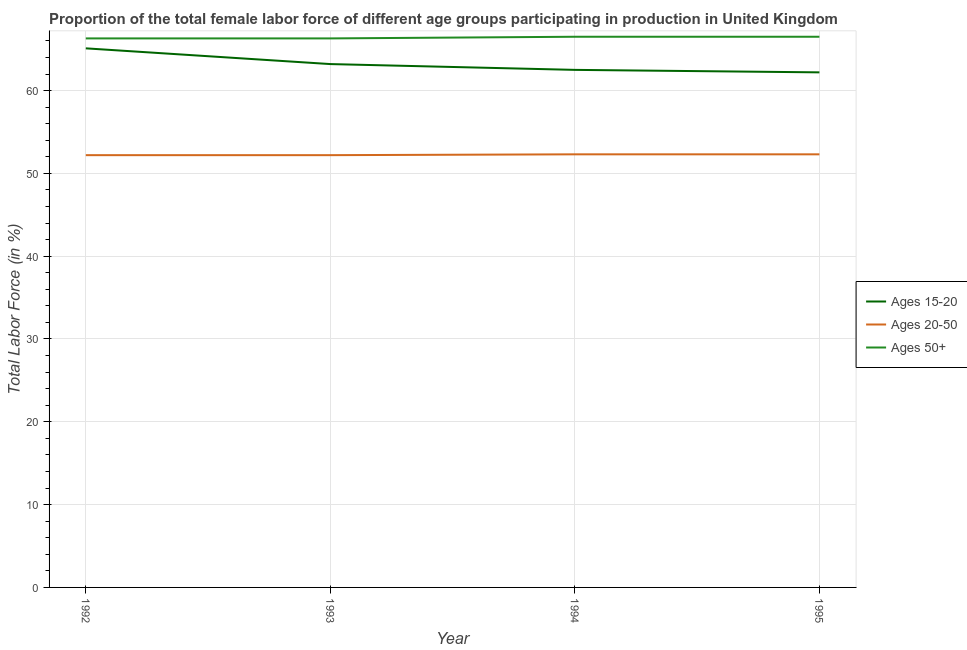How many different coloured lines are there?
Ensure brevity in your answer.  3. Is the number of lines equal to the number of legend labels?
Provide a short and direct response. Yes. What is the percentage of female labor force within the age group 15-20 in 1993?
Offer a very short reply. 63.2. Across all years, what is the maximum percentage of female labor force within the age group 20-50?
Keep it short and to the point. 52.3. Across all years, what is the minimum percentage of female labor force within the age group 20-50?
Provide a succinct answer. 52.2. In which year was the percentage of female labor force within the age group 20-50 maximum?
Give a very brief answer. 1994. What is the total percentage of female labor force within the age group 20-50 in the graph?
Your answer should be compact. 209. What is the difference between the percentage of female labor force above age 50 in 1993 and that in 1995?
Your answer should be compact. -0.2. What is the difference between the percentage of female labor force within the age group 20-50 in 1992 and the percentage of female labor force above age 50 in 1993?
Offer a very short reply. -14.1. What is the average percentage of female labor force within the age group 20-50 per year?
Provide a succinct answer. 52.25. In the year 1995, what is the difference between the percentage of female labor force within the age group 20-50 and percentage of female labor force within the age group 15-20?
Your response must be concise. -9.9. What is the ratio of the percentage of female labor force within the age group 15-20 in 1993 to that in 1995?
Give a very brief answer. 1.02. Is the percentage of female labor force above age 50 in 1992 less than that in 1995?
Your answer should be compact. Yes. What is the difference between the highest and the second highest percentage of female labor force within the age group 15-20?
Your answer should be compact. 1.9. What is the difference between the highest and the lowest percentage of female labor force above age 50?
Provide a short and direct response. 0.2. Is the sum of the percentage of female labor force within the age group 15-20 in 1993 and 1994 greater than the maximum percentage of female labor force within the age group 20-50 across all years?
Offer a terse response. Yes. Is the percentage of female labor force within the age group 15-20 strictly less than the percentage of female labor force above age 50 over the years?
Provide a short and direct response. Yes. How many years are there in the graph?
Provide a short and direct response. 4. What is the difference between two consecutive major ticks on the Y-axis?
Keep it short and to the point. 10. Where does the legend appear in the graph?
Your answer should be very brief. Center right. How many legend labels are there?
Keep it short and to the point. 3. How are the legend labels stacked?
Your answer should be compact. Vertical. What is the title of the graph?
Offer a terse response. Proportion of the total female labor force of different age groups participating in production in United Kingdom. Does "Errors" appear as one of the legend labels in the graph?
Provide a short and direct response. No. What is the label or title of the Y-axis?
Offer a terse response. Total Labor Force (in %). What is the Total Labor Force (in %) of Ages 15-20 in 1992?
Offer a very short reply. 65.1. What is the Total Labor Force (in %) of Ages 20-50 in 1992?
Ensure brevity in your answer.  52.2. What is the Total Labor Force (in %) of Ages 50+ in 1992?
Keep it short and to the point. 66.3. What is the Total Labor Force (in %) of Ages 15-20 in 1993?
Your response must be concise. 63.2. What is the Total Labor Force (in %) in Ages 20-50 in 1993?
Your answer should be compact. 52.2. What is the Total Labor Force (in %) of Ages 50+ in 1993?
Ensure brevity in your answer.  66.3. What is the Total Labor Force (in %) in Ages 15-20 in 1994?
Offer a very short reply. 62.5. What is the Total Labor Force (in %) of Ages 20-50 in 1994?
Make the answer very short. 52.3. What is the Total Labor Force (in %) of Ages 50+ in 1994?
Provide a succinct answer. 66.5. What is the Total Labor Force (in %) in Ages 15-20 in 1995?
Your response must be concise. 62.2. What is the Total Labor Force (in %) of Ages 20-50 in 1995?
Give a very brief answer. 52.3. What is the Total Labor Force (in %) in Ages 50+ in 1995?
Provide a short and direct response. 66.5. Across all years, what is the maximum Total Labor Force (in %) in Ages 15-20?
Your answer should be compact. 65.1. Across all years, what is the maximum Total Labor Force (in %) of Ages 20-50?
Provide a succinct answer. 52.3. Across all years, what is the maximum Total Labor Force (in %) in Ages 50+?
Keep it short and to the point. 66.5. Across all years, what is the minimum Total Labor Force (in %) of Ages 15-20?
Your response must be concise. 62.2. Across all years, what is the minimum Total Labor Force (in %) in Ages 20-50?
Offer a terse response. 52.2. Across all years, what is the minimum Total Labor Force (in %) in Ages 50+?
Provide a succinct answer. 66.3. What is the total Total Labor Force (in %) in Ages 15-20 in the graph?
Provide a succinct answer. 253. What is the total Total Labor Force (in %) in Ages 20-50 in the graph?
Give a very brief answer. 209. What is the total Total Labor Force (in %) of Ages 50+ in the graph?
Provide a short and direct response. 265.6. What is the difference between the Total Labor Force (in %) in Ages 20-50 in 1992 and that in 1993?
Your answer should be very brief. 0. What is the difference between the Total Labor Force (in %) of Ages 20-50 in 1992 and that in 1994?
Provide a succinct answer. -0.1. What is the difference between the Total Labor Force (in %) of Ages 20-50 in 1992 and that in 1995?
Your answer should be compact. -0.1. What is the difference between the Total Labor Force (in %) of Ages 50+ in 1992 and that in 1995?
Keep it short and to the point. -0.2. What is the difference between the Total Labor Force (in %) in Ages 15-20 in 1993 and that in 1994?
Offer a terse response. 0.7. What is the difference between the Total Labor Force (in %) of Ages 50+ in 1993 and that in 1994?
Your answer should be compact. -0.2. What is the difference between the Total Labor Force (in %) in Ages 15-20 in 1993 and that in 1995?
Offer a very short reply. 1. What is the difference between the Total Labor Force (in %) of Ages 20-50 in 1993 and that in 1995?
Offer a very short reply. -0.1. What is the difference between the Total Labor Force (in %) of Ages 15-20 in 1994 and that in 1995?
Ensure brevity in your answer.  0.3. What is the difference between the Total Labor Force (in %) of Ages 20-50 in 1994 and that in 1995?
Your answer should be very brief. 0. What is the difference between the Total Labor Force (in %) in Ages 15-20 in 1992 and the Total Labor Force (in %) in Ages 20-50 in 1993?
Offer a very short reply. 12.9. What is the difference between the Total Labor Force (in %) in Ages 15-20 in 1992 and the Total Labor Force (in %) in Ages 50+ in 1993?
Your answer should be very brief. -1.2. What is the difference between the Total Labor Force (in %) in Ages 20-50 in 1992 and the Total Labor Force (in %) in Ages 50+ in 1993?
Ensure brevity in your answer.  -14.1. What is the difference between the Total Labor Force (in %) of Ages 15-20 in 1992 and the Total Labor Force (in %) of Ages 20-50 in 1994?
Make the answer very short. 12.8. What is the difference between the Total Labor Force (in %) of Ages 15-20 in 1992 and the Total Labor Force (in %) of Ages 50+ in 1994?
Provide a short and direct response. -1.4. What is the difference between the Total Labor Force (in %) in Ages 20-50 in 1992 and the Total Labor Force (in %) in Ages 50+ in 1994?
Make the answer very short. -14.3. What is the difference between the Total Labor Force (in %) of Ages 15-20 in 1992 and the Total Labor Force (in %) of Ages 20-50 in 1995?
Your answer should be very brief. 12.8. What is the difference between the Total Labor Force (in %) in Ages 15-20 in 1992 and the Total Labor Force (in %) in Ages 50+ in 1995?
Your answer should be compact. -1.4. What is the difference between the Total Labor Force (in %) of Ages 20-50 in 1992 and the Total Labor Force (in %) of Ages 50+ in 1995?
Give a very brief answer. -14.3. What is the difference between the Total Labor Force (in %) of Ages 15-20 in 1993 and the Total Labor Force (in %) of Ages 20-50 in 1994?
Your response must be concise. 10.9. What is the difference between the Total Labor Force (in %) in Ages 20-50 in 1993 and the Total Labor Force (in %) in Ages 50+ in 1994?
Provide a succinct answer. -14.3. What is the difference between the Total Labor Force (in %) in Ages 15-20 in 1993 and the Total Labor Force (in %) in Ages 50+ in 1995?
Ensure brevity in your answer.  -3.3. What is the difference between the Total Labor Force (in %) in Ages 20-50 in 1993 and the Total Labor Force (in %) in Ages 50+ in 1995?
Make the answer very short. -14.3. What is the difference between the Total Labor Force (in %) of Ages 15-20 in 1994 and the Total Labor Force (in %) of Ages 50+ in 1995?
Offer a terse response. -4. What is the difference between the Total Labor Force (in %) in Ages 20-50 in 1994 and the Total Labor Force (in %) in Ages 50+ in 1995?
Provide a short and direct response. -14.2. What is the average Total Labor Force (in %) in Ages 15-20 per year?
Ensure brevity in your answer.  63.25. What is the average Total Labor Force (in %) of Ages 20-50 per year?
Offer a terse response. 52.25. What is the average Total Labor Force (in %) of Ages 50+ per year?
Provide a succinct answer. 66.4. In the year 1992, what is the difference between the Total Labor Force (in %) in Ages 15-20 and Total Labor Force (in %) in Ages 20-50?
Ensure brevity in your answer.  12.9. In the year 1992, what is the difference between the Total Labor Force (in %) of Ages 15-20 and Total Labor Force (in %) of Ages 50+?
Keep it short and to the point. -1.2. In the year 1992, what is the difference between the Total Labor Force (in %) in Ages 20-50 and Total Labor Force (in %) in Ages 50+?
Keep it short and to the point. -14.1. In the year 1993, what is the difference between the Total Labor Force (in %) in Ages 15-20 and Total Labor Force (in %) in Ages 20-50?
Offer a very short reply. 11. In the year 1993, what is the difference between the Total Labor Force (in %) of Ages 20-50 and Total Labor Force (in %) of Ages 50+?
Offer a terse response. -14.1. In the year 1994, what is the difference between the Total Labor Force (in %) of Ages 15-20 and Total Labor Force (in %) of Ages 50+?
Keep it short and to the point. -4. In the year 1995, what is the difference between the Total Labor Force (in %) of Ages 15-20 and Total Labor Force (in %) of Ages 50+?
Your answer should be compact. -4.3. What is the ratio of the Total Labor Force (in %) of Ages 15-20 in 1992 to that in 1993?
Provide a succinct answer. 1.03. What is the ratio of the Total Labor Force (in %) in Ages 50+ in 1992 to that in 1993?
Offer a very short reply. 1. What is the ratio of the Total Labor Force (in %) in Ages 15-20 in 1992 to that in 1994?
Your answer should be compact. 1.04. What is the ratio of the Total Labor Force (in %) of Ages 20-50 in 1992 to that in 1994?
Your answer should be compact. 1. What is the ratio of the Total Labor Force (in %) in Ages 50+ in 1992 to that in 1994?
Offer a very short reply. 1. What is the ratio of the Total Labor Force (in %) in Ages 15-20 in 1992 to that in 1995?
Ensure brevity in your answer.  1.05. What is the ratio of the Total Labor Force (in %) of Ages 15-20 in 1993 to that in 1994?
Keep it short and to the point. 1.01. What is the ratio of the Total Labor Force (in %) in Ages 20-50 in 1993 to that in 1994?
Provide a succinct answer. 1. What is the ratio of the Total Labor Force (in %) in Ages 50+ in 1993 to that in 1994?
Ensure brevity in your answer.  1. What is the ratio of the Total Labor Force (in %) in Ages 15-20 in 1993 to that in 1995?
Offer a terse response. 1.02. What is the ratio of the Total Labor Force (in %) of Ages 50+ in 1993 to that in 1995?
Your answer should be very brief. 1. What is the ratio of the Total Labor Force (in %) of Ages 15-20 in 1994 to that in 1995?
Offer a very short reply. 1. What is the ratio of the Total Labor Force (in %) in Ages 20-50 in 1994 to that in 1995?
Make the answer very short. 1. What is the difference between the highest and the second highest Total Labor Force (in %) in Ages 15-20?
Offer a very short reply. 1.9. What is the difference between the highest and the second highest Total Labor Force (in %) of Ages 50+?
Keep it short and to the point. 0. What is the difference between the highest and the lowest Total Labor Force (in %) of Ages 20-50?
Offer a very short reply. 0.1. What is the difference between the highest and the lowest Total Labor Force (in %) in Ages 50+?
Your response must be concise. 0.2. 